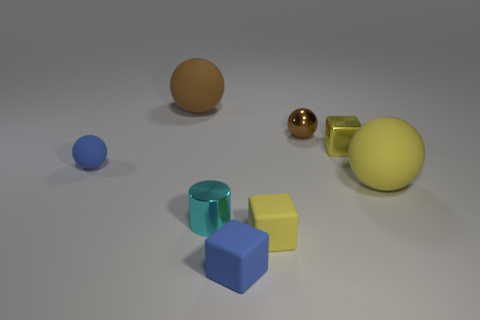Add 1 big purple rubber cylinders. How many objects exist? 9 Subtract all gray balls. Subtract all red cylinders. How many balls are left? 4 Subtract all blocks. How many objects are left? 5 Subtract 2 yellow cubes. How many objects are left? 6 Subtract all small purple rubber cylinders. Subtract all tiny cyan metal things. How many objects are left? 7 Add 7 tiny blue rubber spheres. How many tiny blue rubber spheres are left? 8 Add 4 shiny cylinders. How many shiny cylinders exist? 5 